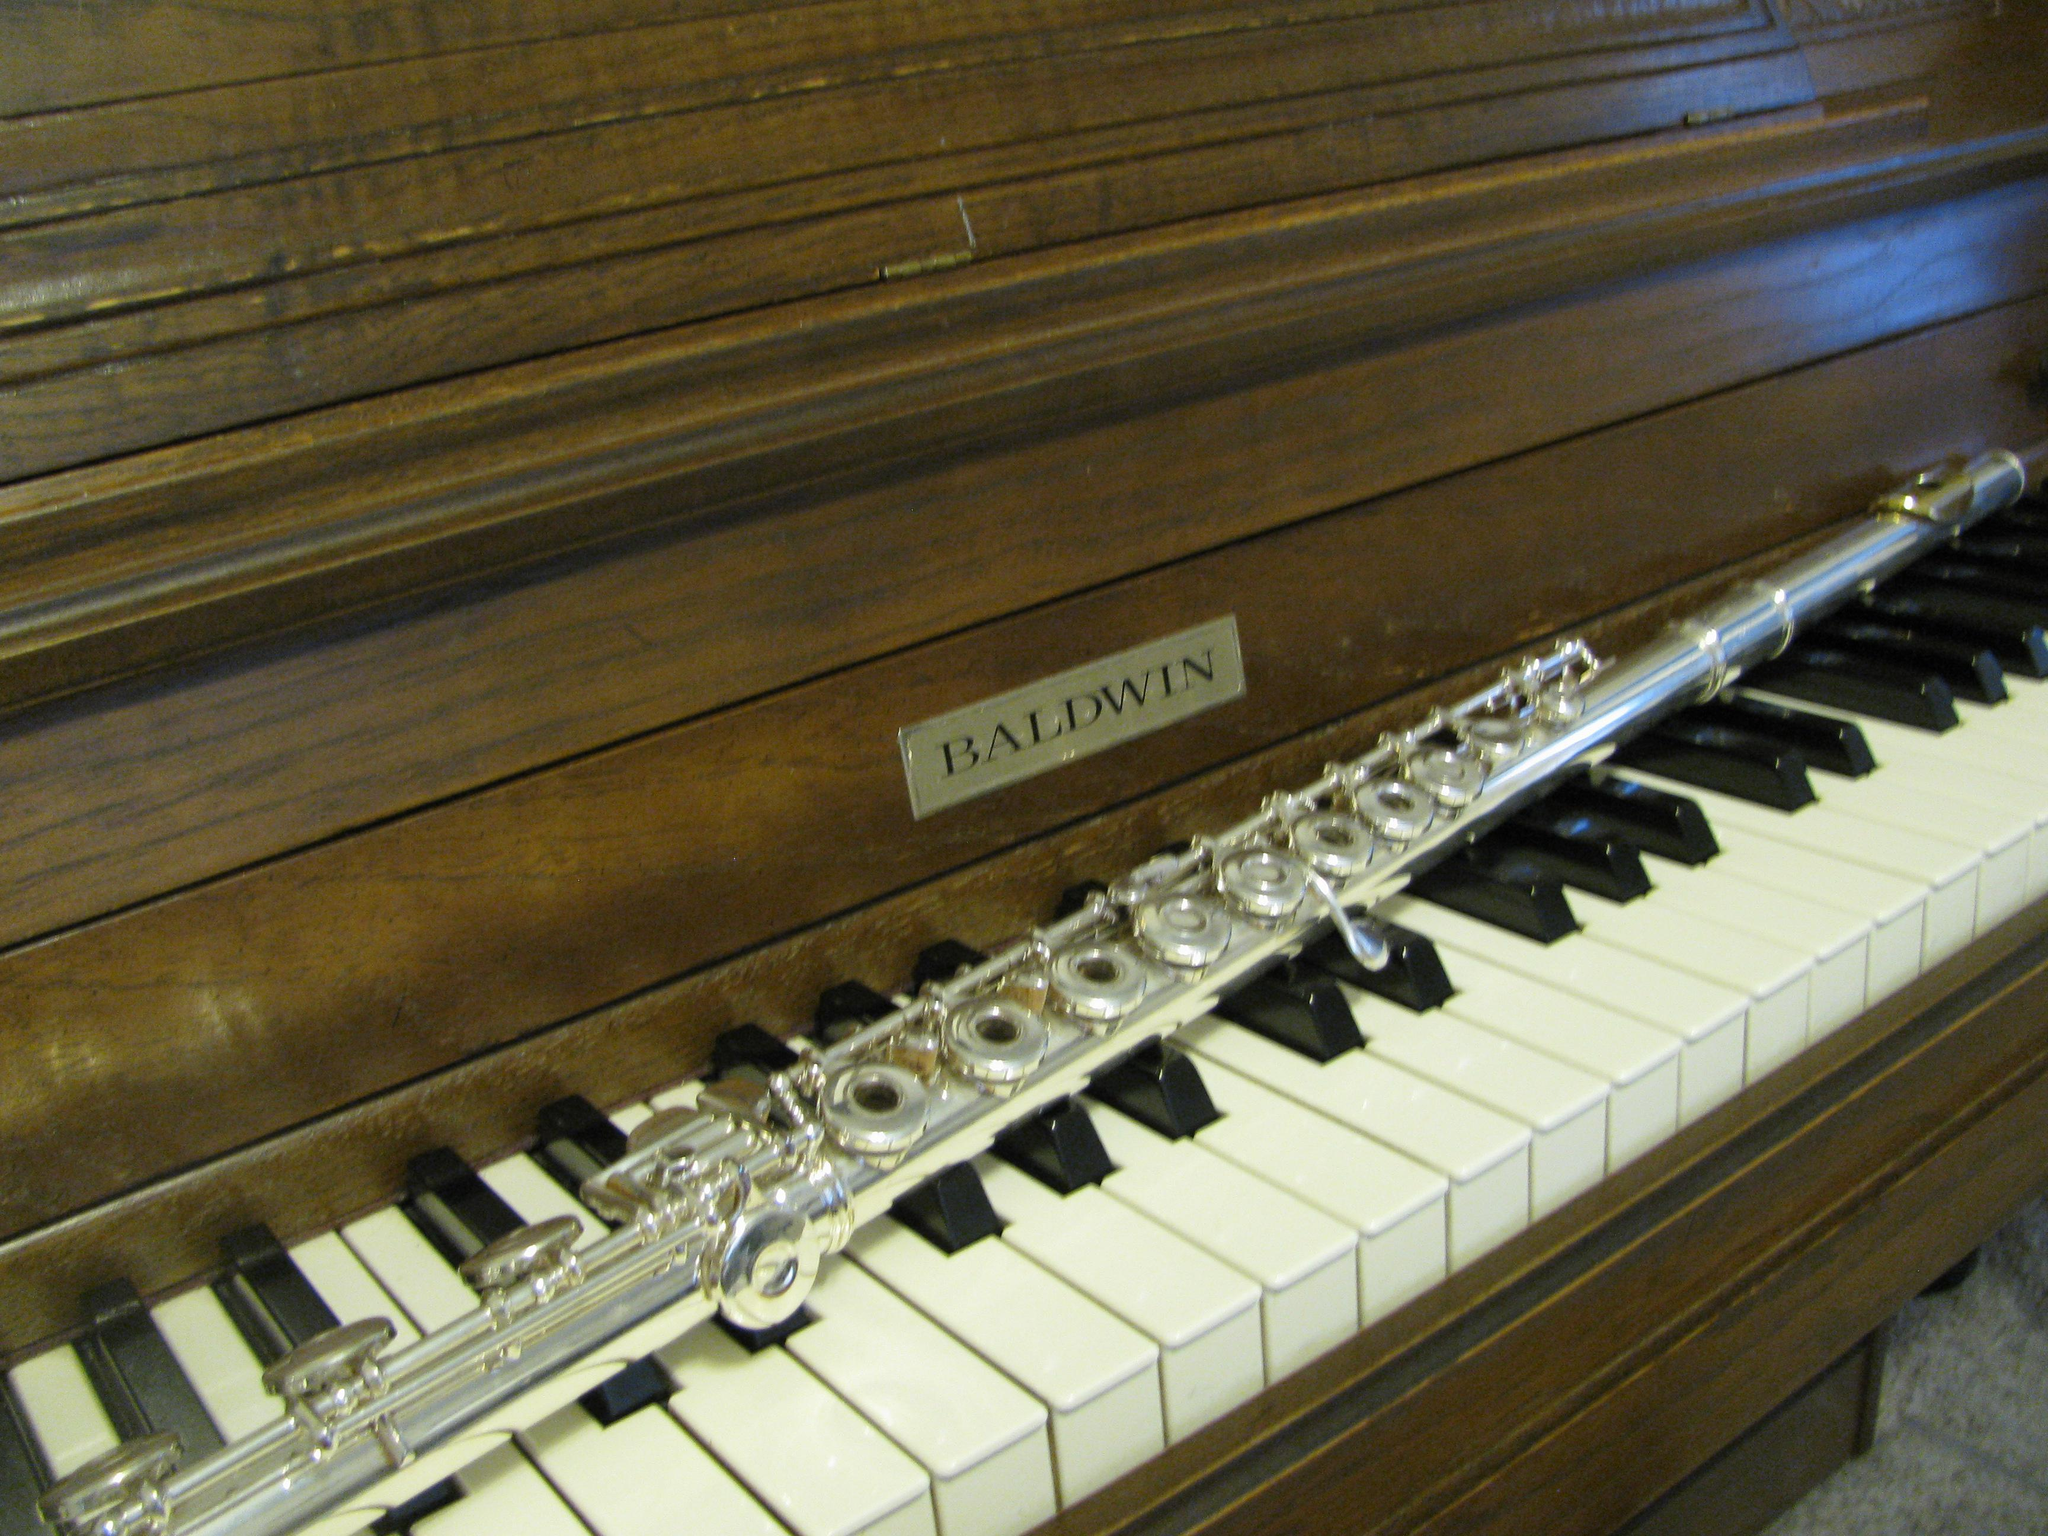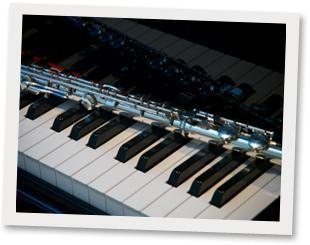The first image is the image on the left, the second image is the image on the right. Analyze the images presented: Is the assertion "An image shows one silver wind instrument laid at an angle across the keys of a brown wood-grain piano that faces rightward." valid? Answer yes or no. Yes. The first image is the image on the left, the second image is the image on the right. Considering the images on both sides, is "There is exactly one flute resting on piano keys." valid? Answer yes or no. No. 